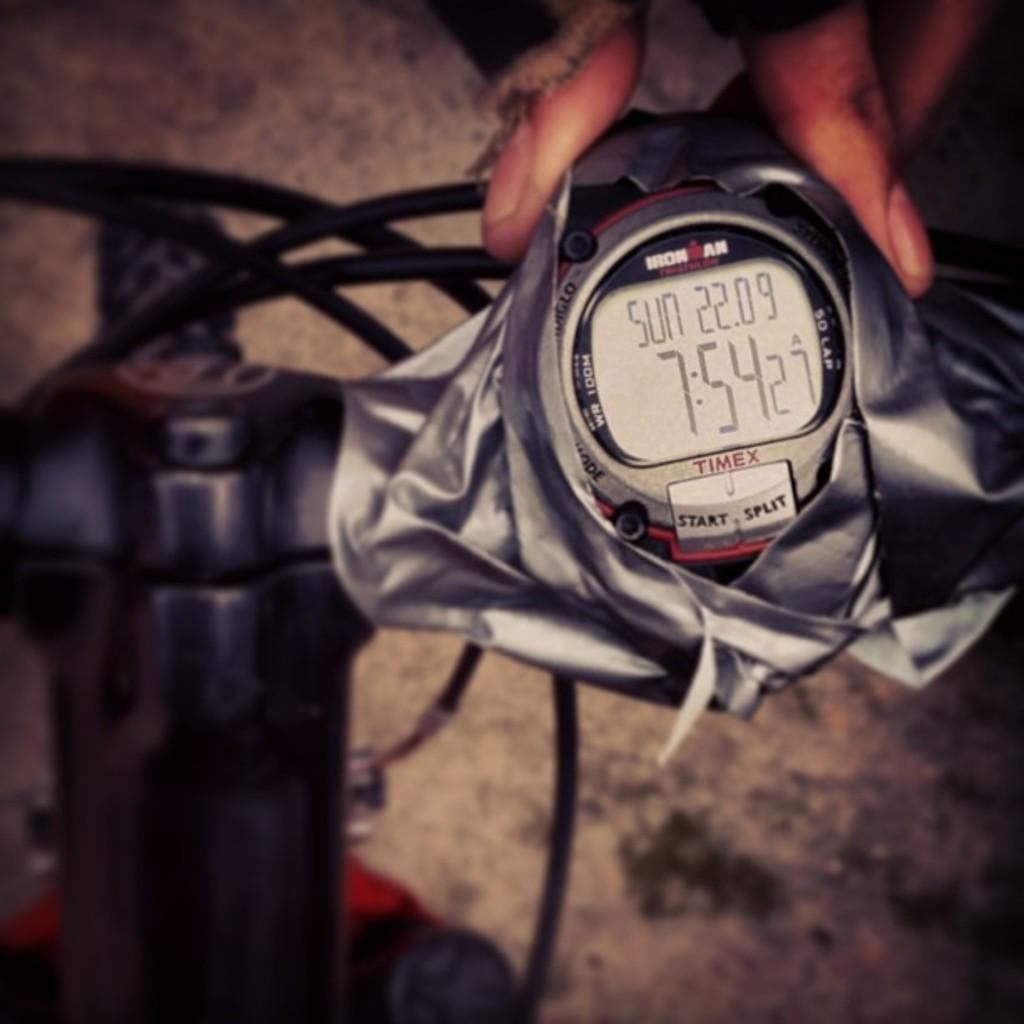<image>
Summarize the visual content of the image. A gray timex branded watch that has the time as 7:54 on its face. 